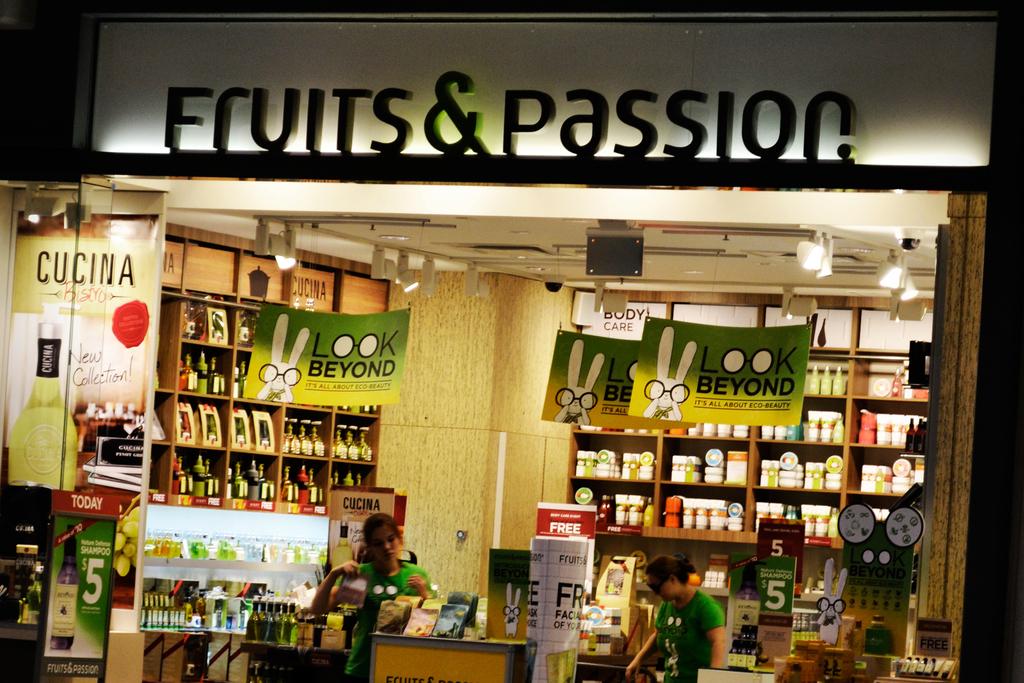What does the green sign say?
Make the answer very short. Look beyond. Is this a fruit store?
Your response must be concise. Yes. 